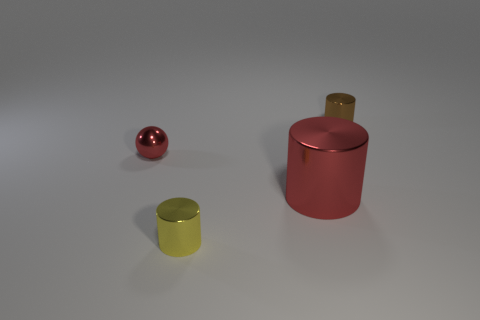Add 4 large red things. How many objects exist? 8 Subtract all cylinders. How many objects are left? 1 Add 3 tiny red metal balls. How many tiny red metal balls exist? 4 Subtract 0 brown cubes. How many objects are left? 4 Subtract all tiny red spheres. Subtract all tiny yellow cylinders. How many objects are left? 2 Add 1 cylinders. How many cylinders are left? 4 